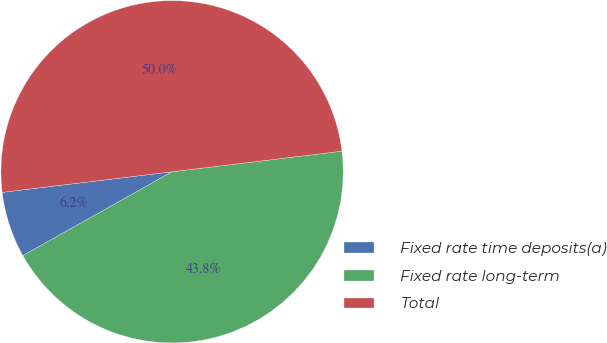Convert chart to OTSL. <chart><loc_0><loc_0><loc_500><loc_500><pie_chart><fcel>Fixed rate time deposits(a)<fcel>Fixed rate long-term<fcel>Total<nl><fcel>6.23%<fcel>43.77%<fcel>50.0%<nl></chart> 